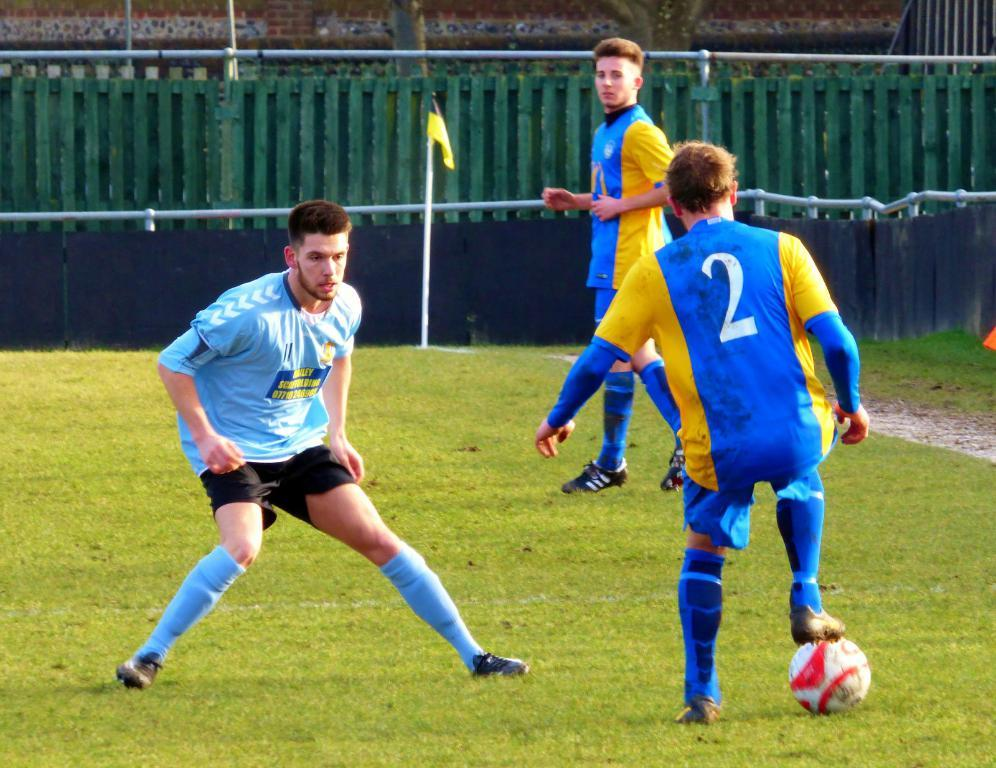<image>
Give a short and clear explanation of the subsequent image. Soccer player wearing number 2 playing against another player. 